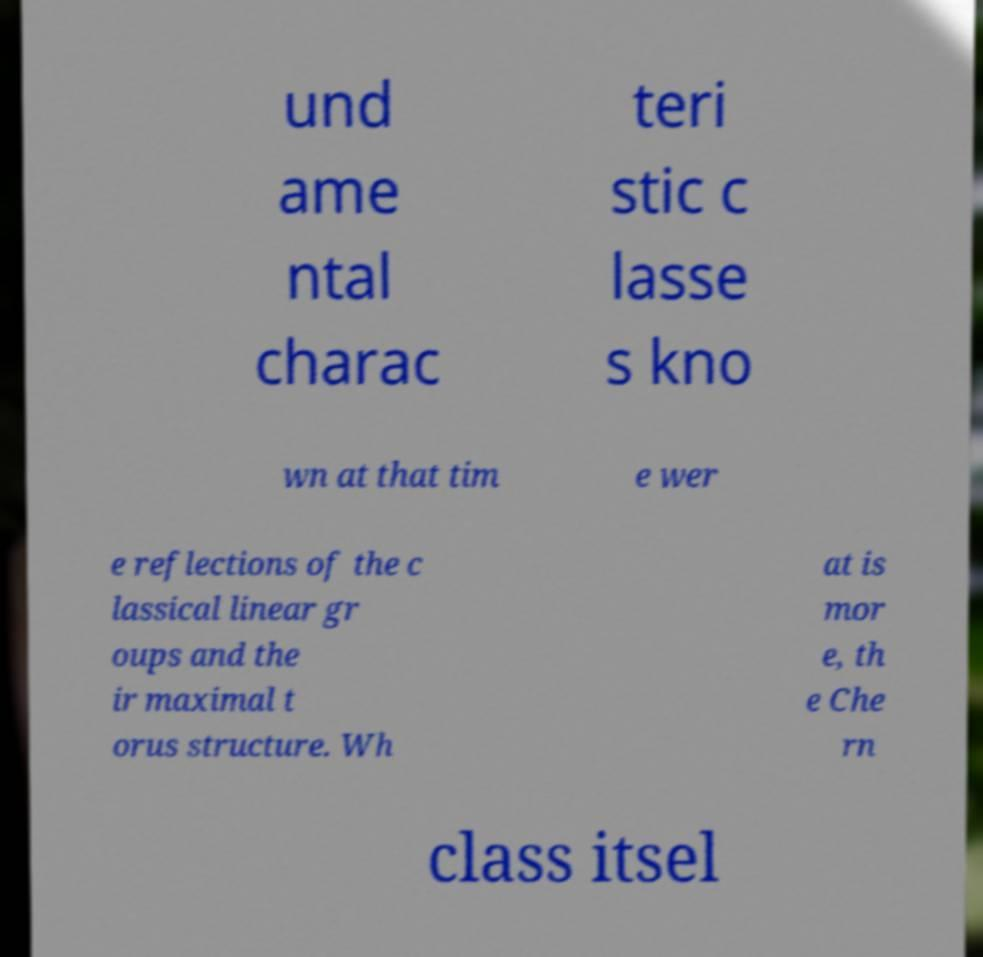What messages or text are displayed in this image? I need them in a readable, typed format. und ame ntal charac teri stic c lasse s kno wn at that tim e wer e reflections of the c lassical linear gr oups and the ir maximal t orus structure. Wh at is mor e, th e Che rn class itsel 